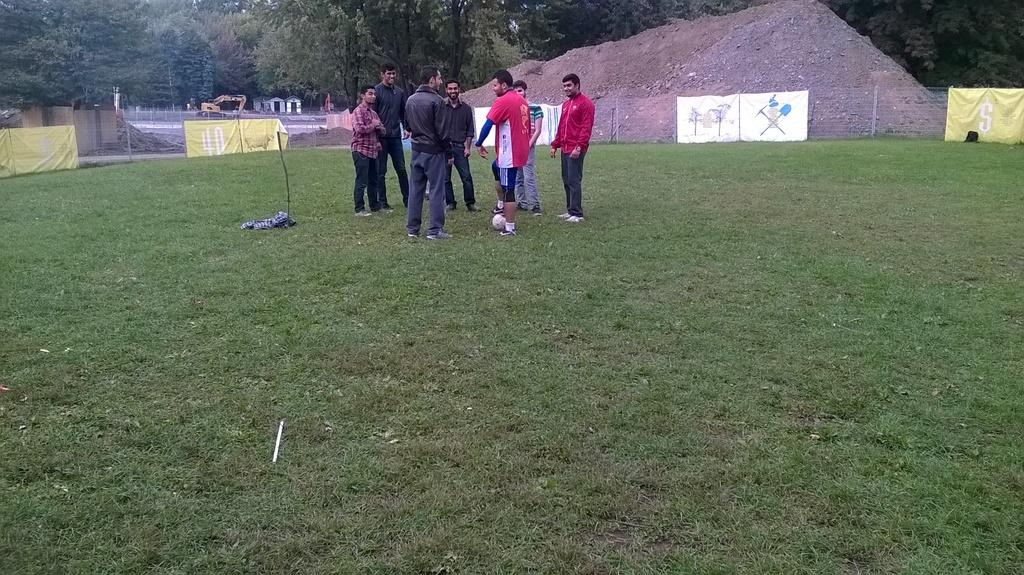What is the surface that the persons are standing on in the image? The persons are standing on a greenery ground in the image. What can be seen in the background behind the persons? There is a fence and trees in the background, as well as other objects. What type of arm is visible in the image? There is no arm visible in the image; the focus is on the persons standing on the greenery ground and the background elements. 